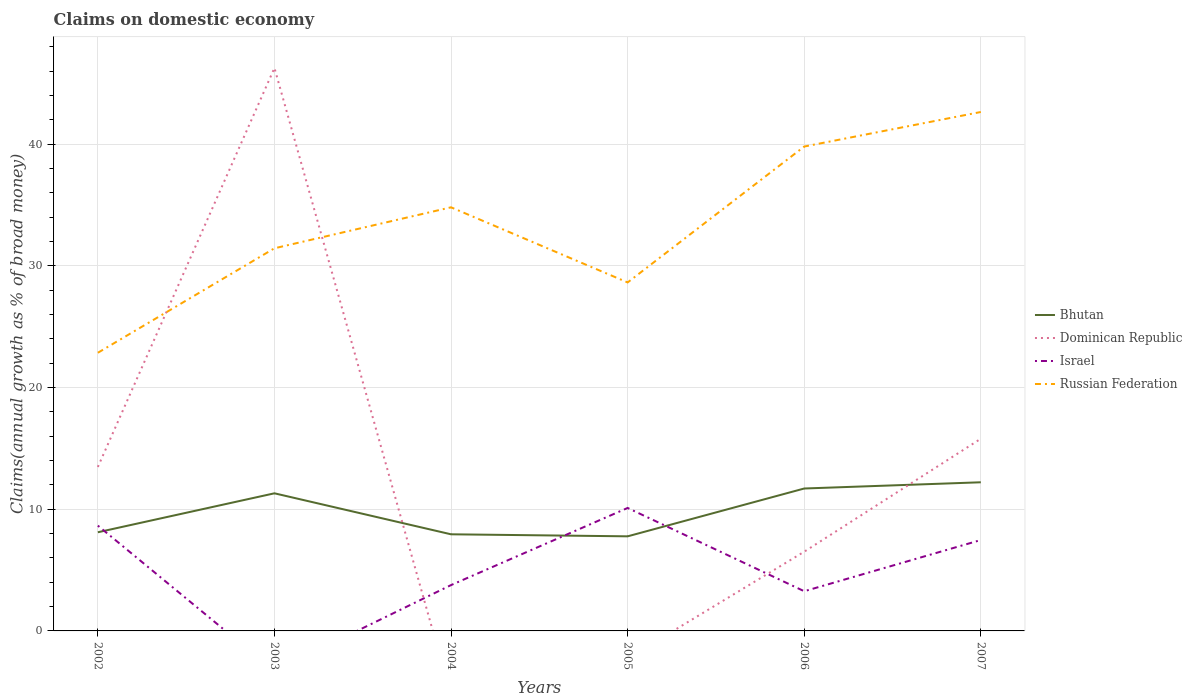Does the line corresponding to Bhutan intersect with the line corresponding to Dominican Republic?
Give a very brief answer. Yes. What is the total percentage of broad money claimed on domestic economy in Israel in the graph?
Provide a succinct answer. 0.51. What is the difference between the highest and the second highest percentage of broad money claimed on domestic economy in Israel?
Your answer should be very brief. 10.1. What is the difference between the highest and the lowest percentage of broad money claimed on domestic economy in Dominican Republic?
Offer a terse response. 2. Is the percentage of broad money claimed on domestic economy in Russian Federation strictly greater than the percentage of broad money claimed on domestic economy in Israel over the years?
Your response must be concise. No. How many lines are there?
Your response must be concise. 4. How many years are there in the graph?
Provide a succinct answer. 6. What is the difference between two consecutive major ticks on the Y-axis?
Provide a succinct answer. 10. Does the graph contain any zero values?
Provide a short and direct response. Yes. What is the title of the graph?
Your response must be concise. Claims on domestic economy. What is the label or title of the Y-axis?
Keep it short and to the point. Claims(annual growth as % of broad money). What is the Claims(annual growth as % of broad money) in Bhutan in 2002?
Keep it short and to the point. 8.11. What is the Claims(annual growth as % of broad money) of Dominican Republic in 2002?
Provide a short and direct response. 13.47. What is the Claims(annual growth as % of broad money) in Israel in 2002?
Ensure brevity in your answer.  8.65. What is the Claims(annual growth as % of broad money) of Russian Federation in 2002?
Offer a terse response. 22.86. What is the Claims(annual growth as % of broad money) of Bhutan in 2003?
Ensure brevity in your answer.  11.31. What is the Claims(annual growth as % of broad money) in Dominican Republic in 2003?
Your response must be concise. 46.26. What is the Claims(annual growth as % of broad money) in Russian Federation in 2003?
Provide a short and direct response. 31.44. What is the Claims(annual growth as % of broad money) of Bhutan in 2004?
Provide a short and direct response. 7.94. What is the Claims(annual growth as % of broad money) of Israel in 2004?
Ensure brevity in your answer.  3.77. What is the Claims(annual growth as % of broad money) in Russian Federation in 2004?
Your response must be concise. 34.81. What is the Claims(annual growth as % of broad money) of Bhutan in 2005?
Give a very brief answer. 7.77. What is the Claims(annual growth as % of broad money) in Dominican Republic in 2005?
Provide a short and direct response. 0. What is the Claims(annual growth as % of broad money) in Israel in 2005?
Your answer should be compact. 10.1. What is the Claims(annual growth as % of broad money) in Russian Federation in 2005?
Your answer should be very brief. 28.63. What is the Claims(annual growth as % of broad money) in Bhutan in 2006?
Provide a short and direct response. 11.7. What is the Claims(annual growth as % of broad money) of Dominican Republic in 2006?
Keep it short and to the point. 6.51. What is the Claims(annual growth as % of broad money) of Israel in 2006?
Your answer should be very brief. 3.26. What is the Claims(annual growth as % of broad money) of Russian Federation in 2006?
Provide a succinct answer. 39.8. What is the Claims(annual growth as % of broad money) of Bhutan in 2007?
Your answer should be very brief. 12.21. What is the Claims(annual growth as % of broad money) in Dominican Republic in 2007?
Give a very brief answer. 15.79. What is the Claims(annual growth as % of broad money) in Israel in 2007?
Keep it short and to the point. 7.47. What is the Claims(annual growth as % of broad money) in Russian Federation in 2007?
Make the answer very short. 42.64. Across all years, what is the maximum Claims(annual growth as % of broad money) in Bhutan?
Offer a very short reply. 12.21. Across all years, what is the maximum Claims(annual growth as % of broad money) in Dominican Republic?
Make the answer very short. 46.26. Across all years, what is the maximum Claims(annual growth as % of broad money) in Israel?
Offer a terse response. 10.1. Across all years, what is the maximum Claims(annual growth as % of broad money) of Russian Federation?
Give a very brief answer. 42.64. Across all years, what is the minimum Claims(annual growth as % of broad money) of Bhutan?
Provide a short and direct response. 7.77. Across all years, what is the minimum Claims(annual growth as % of broad money) of Israel?
Your answer should be compact. 0. Across all years, what is the minimum Claims(annual growth as % of broad money) of Russian Federation?
Your answer should be very brief. 22.86. What is the total Claims(annual growth as % of broad money) of Bhutan in the graph?
Your answer should be compact. 59.04. What is the total Claims(annual growth as % of broad money) in Dominican Republic in the graph?
Provide a short and direct response. 82.03. What is the total Claims(annual growth as % of broad money) in Israel in the graph?
Provide a succinct answer. 33.25. What is the total Claims(annual growth as % of broad money) of Russian Federation in the graph?
Provide a succinct answer. 200.18. What is the difference between the Claims(annual growth as % of broad money) in Bhutan in 2002 and that in 2003?
Offer a terse response. -3.2. What is the difference between the Claims(annual growth as % of broad money) in Dominican Republic in 2002 and that in 2003?
Give a very brief answer. -32.79. What is the difference between the Claims(annual growth as % of broad money) of Russian Federation in 2002 and that in 2003?
Your response must be concise. -8.59. What is the difference between the Claims(annual growth as % of broad money) in Bhutan in 2002 and that in 2004?
Offer a terse response. 0.17. What is the difference between the Claims(annual growth as % of broad money) of Israel in 2002 and that in 2004?
Your answer should be very brief. 4.89. What is the difference between the Claims(annual growth as % of broad money) in Russian Federation in 2002 and that in 2004?
Keep it short and to the point. -11.95. What is the difference between the Claims(annual growth as % of broad money) in Bhutan in 2002 and that in 2005?
Offer a terse response. 0.33. What is the difference between the Claims(annual growth as % of broad money) in Israel in 2002 and that in 2005?
Ensure brevity in your answer.  -1.45. What is the difference between the Claims(annual growth as % of broad money) in Russian Federation in 2002 and that in 2005?
Make the answer very short. -5.78. What is the difference between the Claims(annual growth as % of broad money) in Bhutan in 2002 and that in 2006?
Ensure brevity in your answer.  -3.6. What is the difference between the Claims(annual growth as % of broad money) in Dominican Republic in 2002 and that in 2006?
Offer a very short reply. 6.96. What is the difference between the Claims(annual growth as % of broad money) of Israel in 2002 and that in 2006?
Keep it short and to the point. 5.39. What is the difference between the Claims(annual growth as % of broad money) in Russian Federation in 2002 and that in 2006?
Give a very brief answer. -16.95. What is the difference between the Claims(annual growth as % of broad money) in Bhutan in 2002 and that in 2007?
Offer a very short reply. -4.11. What is the difference between the Claims(annual growth as % of broad money) in Dominican Republic in 2002 and that in 2007?
Provide a succinct answer. -2.32. What is the difference between the Claims(annual growth as % of broad money) of Israel in 2002 and that in 2007?
Provide a short and direct response. 1.18. What is the difference between the Claims(annual growth as % of broad money) in Russian Federation in 2002 and that in 2007?
Keep it short and to the point. -19.78. What is the difference between the Claims(annual growth as % of broad money) of Bhutan in 2003 and that in 2004?
Give a very brief answer. 3.37. What is the difference between the Claims(annual growth as % of broad money) in Russian Federation in 2003 and that in 2004?
Provide a succinct answer. -3.37. What is the difference between the Claims(annual growth as % of broad money) in Bhutan in 2003 and that in 2005?
Provide a succinct answer. 3.54. What is the difference between the Claims(annual growth as % of broad money) of Russian Federation in 2003 and that in 2005?
Provide a succinct answer. 2.81. What is the difference between the Claims(annual growth as % of broad money) of Bhutan in 2003 and that in 2006?
Ensure brevity in your answer.  -0.39. What is the difference between the Claims(annual growth as % of broad money) in Dominican Republic in 2003 and that in 2006?
Provide a short and direct response. 39.75. What is the difference between the Claims(annual growth as % of broad money) in Russian Federation in 2003 and that in 2006?
Your answer should be compact. -8.36. What is the difference between the Claims(annual growth as % of broad money) of Bhutan in 2003 and that in 2007?
Keep it short and to the point. -0.91. What is the difference between the Claims(annual growth as % of broad money) of Dominican Republic in 2003 and that in 2007?
Provide a short and direct response. 30.47. What is the difference between the Claims(annual growth as % of broad money) of Russian Federation in 2003 and that in 2007?
Provide a short and direct response. -11.2. What is the difference between the Claims(annual growth as % of broad money) of Bhutan in 2004 and that in 2005?
Offer a very short reply. 0.17. What is the difference between the Claims(annual growth as % of broad money) in Israel in 2004 and that in 2005?
Keep it short and to the point. -6.34. What is the difference between the Claims(annual growth as % of broad money) of Russian Federation in 2004 and that in 2005?
Make the answer very short. 6.17. What is the difference between the Claims(annual growth as % of broad money) in Bhutan in 2004 and that in 2006?
Offer a very short reply. -3.76. What is the difference between the Claims(annual growth as % of broad money) of Israel in 2004 and that in 2006?
Offer a terse response. 0.51. What is the difference between the Claims(annual growth as % of broad money) in Russian Federation in 2004 and that in 2006?
Provide a succinct answer. -4.99. What is the difference between the Claims(annual growth as % of broad money) in Bhutan in 2004 and that in 2007?
Give a very brief answer. -4.28. What is the difference between the Claims(annual growth as % of broad money) in Israel in 2004 and that in 2007?
Keep it short and to the point. -3.7. What is the difference between the Claims(annual growth as % of broad money) of Russian Federation in 2004 and that in 2007?
Offer a very short reply. -7.83. What is the difference between the Claims(annual growth as % of broad money) of Bhutan in 2005 and that in 2006?
Ensure brevity in your answer.  -3.93. What is the difference between the Claims(annual growth as % of broad money) of Israel in 2005 and that in 2006?
Give a very brief answer. 6.84. What is the difference between the Claims(annual growth as % of broad money) in Russian Federation in 2005 and that in 2006?
Provide a short and direct response. -11.17. What is the difference between the Claims(annual growth as % of broad money) in Bhutan in 2005 and that in 2007?
Provide a short and direct response. -4.44. What is the difference between the Claims(annual growth as % of broad money) in Israel in 2005 and that in 2007?
Your response must be concise. 2.63. What is the difference between the Claims(annual growth as % of broad money) of Russian Federation in 2005 and that in 2007?
Provide a short and direct response. -14. What is the difference between the Claims(annual growth as % of broad money) in Bhutan in 2006 and that in 2007?
Give a very brief answer. -0.51. What is the difference between the Claims(annual growth as % of broad money) of Dominican Republic in 2006 and that in 2007?
Provide a short and direct response. -9.28. What is the difference between the Claims(annual growth as % of broad money) in Israel in 2006 and that in 2007?
Your answer should be very brief. -4.21. What is the difference between the Claims(annual growth as % of broad money) in Russian Federation in 2006 and that in 2007?
Give a very brief answer. -2.84. What is the difference between the Claims(annual growth as % of broad money) in Bhutan in 2002 and the Claims(annual growth as % of broad money) in Dominican Republic in 2003?
Make the answer very short. -38.15. What is the difference between the Claims(annual growth as % of broad money) of Bhutan in 2002 and the Claims(annual growth as % of broad money) of Russian Federation in 2003?
Offer a terse response. -23.33. What is the difference between the Claims(annual growth as % of broad money) of Dominican Republic in 2002 and the Claims(annual growth as % of broad money) of Russian Federation in 2003?
Your answer should be compact. -17.97. What is the difference between the Claims(annual growth as % of broad money) in Israel in 2002 and the Claims(annual growth as % of broad money) in Russian Federation in 2003?
Keep it short and to the point. -22.79. What is the difference between the Claims(annual growth as % of broad money) in Bhutan in 2002 and the Claims(annual growth as % of broad money) in Israel in 2004?
Give a very brief answer. 4.34. What is the difference between the Claims(annual growth as % of broad money) in Bhutan in 2002 and the Claims(annual growth as % of broad money) in Russian Federation in 2004?
Make the answer very short. -26.7. What is the difference between the Claims(annual growth as % of broad money) of Dominican Republic in 2002 and the Claims(annual growth as % of broad money) of Israel in 2004?
Give a very brief answer. 9.71. What is the difference between the Claims(annual growth as % of broad money) in Dominican Republic in 2002 and the Claims(annual growth as % of broad money) in Russian Federation in 2004?
Give a very brief answer. -21.34. What is the difference between the Claims(annual growth as % of broad money) of Israel in 2002 and the Claims(annual growth as % of broad money) of Russian Federation in 2004?
Ensure brevity in your answer.  -26.16. What is the difference between the Claims(annual growth as % of broad money) in Bhutan in 2002 and the Claims(annual growth as % of broad money) in Israel in 2005?
Your answer should be very brief. -2. What is the difference between the Claims(annual growth as % of broad money) in Bhutan in 2002 and the Claims(annual growth as % of broad money) in Russian Federation in 2005?
Make the answer very short. -20.53. What is the difference between the Claims(annual growth as % of broad money) of Dominican Republic in 2002 and the Claims(annual growth as % of broad money) of Israel in 2005?
Your answer should be compact. 3.37. What is the difference between the Claims(annual growth as % of broad money) in Dominican Republic in 2002 and the Claims(annual growth as % of broad money) in Russian Federation in 2005?
Your response must be concise. -15.16. What is the difference between the Claims(annual growth as % of broad money) in Israel in 2002 and the Claims(annual growth as % of broad money) in Russian Federation in 2005?
Offer a terse response. -19.98. What is the difference between the Claims(annual growth as % of broad money) of Bhutan in 2002 and the Claims(annual growth as % of broad money) of Dominican Republic in 2006?
Your answer should be compact. 1.6. What is the difference between the Claims(annual growth as % of broad money) in Bhutan in 2002 and the Claims(annual growth as % of broad money) in Israel in 2006?
Provide a short and direct response. 4.85. What is the difference between the Claims(annual growth as % of broad money) of Bhutan in 2002 and the Claims(annual growth as % of broad money) of Russian Federation in 2006?
Provide a succinct answer. -31.69. What is the difference between the Claims(annual growth as % of broad money) in Dominican Republic in 2002 and the Claims(annual growth as % of broad money) in Israel in 2006?
Keep it short and to the point. 10.21. What is the difference between the Claims(annual growth as % of broad money) in Dominican Republic in 2002 and the Claims(annual growth as % of broad money) in Russian Federation in 2006?
Make the answer very short. -26.33. What is the difference between the Claims(annual growth as % of broad money) in Israel in 2002 and the Claims(annual growth as % of broad money) in Russian Federation in 2006?
Give a very brief answer. -31.15. What is the difference between the Claims(annual growth as % of broad money) in Bhutan in 2002 and the Claims(annual growth as % of broad money) in Dominican Republic in 2007?
Offer a very short reply. -7.69. What is the difference between the Claims(annual growth as % of broad money) in Bhutan in 2002 and the Claims(annual growth as % of broad money) in Israel in 2007?
Provide a short and direct response. 0.64. What is the difference between the Claims(annual growth as % of broad money) of Bhutan in 2002 and the Claims(annual growth as % of broad money) of Russian Federation in 2007?
Your answer should be compact. -34.53. What is the difference between the Claims(annual growth as % of broad money) of Dominican Republic in 2002 and the Claims(annual growth as % of broad money) of Israel in 2007?
Ensure brevity in your answer.  6. What is the difference between the Claims(annual growth as % of broad money) of Dominican Republic in 2002 and the Claims(annual growth as % of broad money) of Russian Federation in 2007?
Provide a short and direct response. -29.17. What is the difference between the Claims(annual growth as % of broad money) in Israel in 2002 and the Claims(annual growth as % of broad money) in Russian Federation in 2007?
Make the answer very short. -33.99. What is the difference between the Claims(annual growth as % of broad money) of Bhutan in 2003 and the Claims(annual growth as % of broad money) of Israel in 2004?
Your response must be concise. 7.54. What is the difference between the Claims(annual growth as % of broad money) of Bhutan in 2003 and the Claims(annual growth as % of broad money) of Russian Federation in 2004?
Provide a short and direct response. -23.5. What is the difference between the Claims(annual growth as % of broad money) of Dominican Republic in 2003 and the Claims(annual growth as % of broad money) of Israel in 2004?
Keep it short and to the point. 42.49. What is the difference between the Claims(annual growth as % of broad money) in Dominican Republic in 2003 and the Claims(annual growth as % of broad money) in Russian Federation in 2004?
Offer a very short reply. 11.45. What is the difference between the Claims(annual growth as % of broad money) of Bhutan in 2003 and the Claims(annual growth as % of broad money) of Israel in 2005?
Keep it short and to the point. 1.2. What is the difference between the Claims(annual growth as % of broad money) of Bhutan in 2003 and the Claims(annual growth as % of broad money) of Russian Federation in 2005?
Your response must be concise. -17.33. What is the difference between the Claims(annual growth as % of broad money) in Dominican Republic in 2003 and the Claims(annual growth as % of broad money) in Israel in 2005?
Keep it short and to the point. 36.15. What is the difference between the Claims(annual growth as % of broad money) in Dominican Republic in 2003 and the Claims(annual growth as % of broad money) in Russian Federation in 2005?
Offer a very short reply. 17.62. What is the difference between the Claims(annual growth as % of broad money) of Bhutan in 2003 and the Claims(annual growth as % of broad money) of Dominican Republic in 2006?
Your answer should be compact. 4.8. What is the difference between the Claims(annual growth as % of broad money) in Bhutan in 2003 and the Claims(annual growth as % of broad money) in Israel in 2006?
Your response must be concise. 8.05. What is the difference between the Claims(annual growth as % of broad money) in Bhutan in 2003 and the Claims(annual growth as % of broad money) in Russian Federation in 2006?
Provide a succinct answer. -28.49. What is the difference between the Claims(annual growth as % of broad money) in Dominican Republic in 2003 and the Claims(annual growth as % of broad money) in Israel in 2006?
Your response must be concise. 43. What is the difference between the Claims(annual growth as % of broad money) in Dominican Republic in 2003 and the Claims(annual growth as % of broad money) in Russian Federation in 2006?
Keep it short and to the point. 6.46. What is the difference between the Claims(annual growth as % of broad money) of Bhutan in 2003 and the Claims(annual growth as % of broad money) of Dominican Republic in 2007?
Your answer should be very brief. -4.48. What is the difference between the Claims(annual growth as % of broad money) in Bhutan in 2003 and the Claims(annual growth as % of broad money) in Israel in 2007?
Offer a terse response. 3.84. What is the difference between the Claims(annual growth as % of broad money) of Bhutan in 2003 and the Claims(annual growth as % of broad money) of Russian Federation in 2007?
Offer a terse response. -31.33. What is the difference between the Claims(annual growth as % of broad money) of Dominican Republic in 2003 and the Claims(annual growth as % of broad money) of Israel in 2007?
Your answer should be very brief. 38.79. What is the difference between the Claims(annual growth as % of broad money) of Dominican Republic in 2003 and the Claims(annual growth as % of broad money) of Russian Federation in 2007?
Offer a very short reply. 3.62. What is the difference between the Claims(annual growth as % of broad money) of Bhutan in 2004 and the Claims(annual growth as % of broad money) of Israel in 2005?
Offer a very short reply. -2.17. What is the difference between the Claims(annual growth as % of broad money) of Bhutan in 2004 and the Claims(annual growth as % of broad money) of Russian Federation in 2005?
Your response must be concise. -20.7. What is the difference between the Claims(annual growth as % of broad money) of Israel in 2004 and the Claims(annual growth as % of broad money) of Russian Federation in 2005?
Ensure brevity in your answer.  -24.87. What is the difference between the Claims(annual growth as % of broad money) in Bhutan in 2004 and the Claims(annual growth as % of broad money) in Dominican Republic in 2006?
Ensure brevity in your answer.  1.43. What is the difference between the Claims(annual growth as % of broad money) in Bhutan in 2004 and the Claims(annual growth as % of broad money) in Israel in 2006?
Give a very brief answer. 4.68. What is the difference between the Claims(annual growth as % of broad money) of Bhutan in 2004 and the Claims(annual growth as % of broad money) of Russian Federation in 2006?
Ensure brevity in your answer.  -31.86. What is the difference between the Claims(annual growth as % of broad money) in Israel in 2004 and the Claims(annual growth as % of broad money) in Russian Federation in 2006?
Your response must be concise. -36.03. What is the difference between the Claims(annual growth as % of broad money) of Bhutan in 2004 and the Claims(annual growth as % of broad money) of Dominican Republic in 2007?
Your answer should be very brief. -7.85. What is the difference between the Claims(annual growth as % of broad money) in Bhutan in 2004 and the Claims(annual growth as % of broad money) in Israel in 2007?
Your answer should be very brief. 0.47. What is the difference between the Claims(annual growth as % of broad money) in Bhutan in 2004 and the Claims(annual growth as % of broad money) in Russian Federation in 2007?
Give a very brief answer. -34.7. What is the difference between the Claims(annual growth as % of broad money) in Israel in 2004 and the Claims(annual growth as % of broad money) in Russian Federation in 2007?
Ensure brevity in your answer.  -38.87. What is the difference between the Claims(annual growth as % of broad money) in Bhutan in 2005 and the Claims(annual growth as % of broad money) in Dominican Republic in 2006?
Give a very brief answer. 1.26. What is the difference between the Claims(annual growth as % of broad money) in Bhutan in 2005 and the Claims(annual growth as % of broad money) in Israel in 2006?
Offer a terse response. 4.51. What is the difference between the Claims(annual growth as % of broad money) in Bhutan in 2005 and the Claims(annual growth as % of broad money) in Russian Federation in 2006?
Your response must be concise. -32.03. What is the difference between the Claims(annual growth as % of broad money) in Israel in 2005 and the Claims(annual growth as % of broad money) in Russian Federation in 2006?
Your answer should be compact. -29.7. What is the difference between the Claims(annual growth as % of broad money) in Bhutan in 2005 and the Claims(annual growth as % of broad money) in Dominican Republic in 2007?
Make the answer very short. -8.02. What is the difference between the Claims(annual growth as % of broad money) in Bhutan in 2005 and the Claims(annual growth as % of broad money) in Israel in 2007?
Offer a very short reply. 0.3. What is the difference between the Claims(annual growth as % of broad money) of Bhutan in 2005 and the Claims(annual growth as % of broad money) of Russian Federation in 2007?
Make the answer very short. -34.87. What is the difference between the Claims(annual growth as % of broad money) in Israel in 2005 and the Claims(annual growth as % of broad money) in Russian Federation in 2007?
Offer a very short reply. -32.54. What is the difference between the Claims(annual growth as % of broad money) in Bhutan in 2006 and the Claims(annual growth as % of broad money) in Dominican Republic in 2007?
Ensure brevity in your answer.  -4.09. What is the difference between the Claims(annual growth as % of broad money) of Bhutan in 2006 and the Claims(annual growth as % of broad money) of Israel in 2007?
Keep it short and to the point. 4.23. What is the difference between the Claims(annual growth as % of broad money) in Bhutan in 2006 and the Claims(annual growth as % of broad money) in Russian Federation in 2007?
Offer a terse response. -30.94. What is the difference between the Claims(annual growth as % of broad money) in Dominican Republic in 2006 and the Claims(annual growth as % of broad money) in Israel in 2007?
Give a very brief answer. -0.96. What is the difference between the Claims(annual growth as % of broad money) in Dominican Republic in 2006 and the Claims(annual growth as % of broad money) in Russian Federation in 2007?
Offer a very short reply. -36.13. What is the difference between the Claims(annual growth as % of broad money) in Israel in 2006 and the Claims(annual growth as % of broad money) in Russian Federation in 2007?
Make the answer very short. -39.38. What is the average Claims(annual growth as % of broad money) of Bhutan per year?
Your response must be concise. 9.84. What is the average Claims(annual growth as % of broad money) of Dominican Republic per year?
Make the answer very short. 13.67. What is the average Claims(annual growth as % of broad money) in Israel per year?
Offer a terse response. 5.54. What is the average Claims(annual growth as % of broad money) in Russian Federation per year?
Your answer should be compact. 33.36. In the year 2002, what is the difference between the Claims(annual growth as % of broad money) of Bhutan and Claims(annual growth as % of broad money) of Dominican Republic?
Ensure brevity in your answer.  -5.37. In the year 2002, what is the difference between the Claims(annual growth as % of broad money) of Bhutan and Claims(annual growth as % of broad money) of Israel?
Give a very brief answer. -0.55. In the year 2002, what is the difference between the Claims(annual growth as % of broad money) in Bhutan and Claims(annual growth as % of broad money) in Russian Federation?
Ensure brevity in your answer.  -14.75. In the year 2002, what is the difference between the Claims(annual growth as % of broad money) in Dominican Republic and Claims(annual growth as % of broad money) in Israel?
Give a very brief answer. 4.82. In the year 2002, what is the difference between the Claims(annual growth as % of broad money) in Dominican Republic and Claims(annual growth as % of broad money) in Russian Federation?
Ensure brevity in your answer.  -9.38. In the year 2002, what is the difference between the Claims(annual growth as % of broad money) in Israel and Claims(annual growth as % of broad money) in Russian Federation?
Offer a very short reply. -14.2. In the year 2003, what is the difference between the Claims(annual growth as % of broad money) of Bhutan and Claims(annual growth as % of broad money) of Dominican Republic?
Ensure brevity in your answer.  -34.95. In the year 2003, what is the difference between the Claims(annual growth as % of broad money) of Bhutan and Claims(annual growth as % of broad money) of Russian Federation?
Offer a terse response. -20.13. In the year 2003, what is the difference between the Claims(annual growth as % of broad money) in Dominican Republic and Claims(annual growth as % of broad money) in Russian Federation?
Provide a succinct answer. 14.82. In the year 2004, what is the difference between the Claims(annual growth as % of broad money) in Bhutan and Claims(annual growth as % of broad money) in Israel?
Ensure brevity in your answer.  4.17. In the year 2004, what is the difference between the Claims(annual growth as % of broad money) of Bhutan and Claims(annual growth as % of broad money) of Russian Federation?
Your response must be concise. -26.87. In the year 2004, what is the difference between the Claims(annual growth as % of broad money) of Israel and Claims(annual growth as % of broad money) of Russian Federation?
Give a very brief answer. -31.04. In the year 2005, what is the difference between the Claims(annual growth as % of broad money) in Bhutan and Claims(annual growth as % of broad money) in Israel?
Keep it short and to the point. -2.33. In the year 2005, what is the difference between the Claims(annual growth as % of broad money) in Bhutan and Claims(annual growth as % of broad money) in Russian Federation?
Provide a short and direct response. -20.86. In the year 2005, what is the difference between the Claims(annual growth as % of broad money) in Israel and Claims(annual growth as % of broad money) in Russian Federation?
Your answer should be compact. -18.53. In the year 2006, what is the difference between the Claims(annual growth as % of broad money) in Bhutan and Claims(annual growth as % of broad money) in Dominican Republic?
Your answer should be very brief. 5.19. In the year 2006, what is the difference between the Claims(annual growth as % of broad money) in Bhutan and Claims(annual growth as % of broad money) in Israel?
Your answer should be compact. 8.44. In the year 2006, what is the difference between the Claims(annual growth as % of broad money) in Bhutan and Claims(annual growth as % of broad money) in Russian Federation?
Provide a short and direct response. -28.1. In the year 2006, what is the difference between the Claims(annual growth as % of broad money) in Dominican Republic and Claims(annual growth as % of broad money) in Israel?
Ensure brevity in your answer.  3.25. In the year 2006, what is the difference between the Claims(annual growth as % of broad money) in Dominican Republic and Claims(annual growth as % of broad money) in Russian Federation?
Give a very brief answer. -33.29. In the year 2006, what is the difference between the Claims(annual growth as % of broad money) of Israel and Claims(annual growth as % of broad money) of Russian Federation?
Keep it short and to the point. -36.54. In the year 2007, what is the difference between the Claims(annual growth as % of broad money) of Bhutan and Claims(annual growth as % of broad money) of Dominican Republic?
Make the answer very short. -3.58. In the year 2007, what is the difference between the Claims(annual growth as % of broad money) in Bhutan and Claims(annual growth as % of broad money) in Israel?
Keep it short and to the point. 4.75. In the year 2007, what is the difference between the Claims(annual growth as % of broad money) of Bhutan and Claims(annual growth as % of broad money) of Russian Federation?
Provide a succinct answer. -30.43. In the year 2007, what is the difference between the Claims(annual growth as % of broad money) in Dominican Republic and Claims(annual growth as % of broad money) in Israel?
Your answer should be very brief. 8.32. In the year 2007, what is the difference between the Claims(annual growth as % of broad money) of Dominican Republic and Claims(annual growth as % of broad money) of Russian Federation?
Offer a very short reply. -26.85. In the year 2007, what is the difference between the Claims(annual growth as % of broad money) of Israel and Claims(annual growth as % of broad money) of Russian Federation?
Offer a very short reply. -35.17. What is the ratio of the Claims(annual growth as % of broad money) of Bhutan in 2002 to that in 2003?
Keep it short and to the point. 0.72. What is the ratio of the Claims(annual growth as % of broad money) of Dominican Republic in 2002 to that in 2003?
Provide a succinct answer. 0.29. What is the ratio of the Claims(annual growth as % of broad money) in Russian Federation in 2002 to that in 2003?
Keep it short and to the point. 0.73. What is the ratio of the Claims(annual growth as % of broad money) in Bhutan in 2002 to that in 2004?
Give a very brief answer. 1.02. What is the ratio of the Claims(annual growth as % of broad money) in Israel in 2002 to that in 2004?
Your answer should be very brief. 2.3. What is the ratio of the Claims(annual growth as % of broad money) in Russian Federation in 2002 to that in 2004?
Your response must be concise. 0.66. What is the ratio of the Claims(annual growth as % of broad money) of Bhutan in 2002 to that in 2005?
Ensure brevity in your answer.  1.04. What is the ratio of the Claims(annual growth as % of broad money) in Israel in 2002 to that in 2005?
Provide a succinct answer. 0.86. What is the ratio of the Claims(annual growth as % of broad money) of Russian Federation in 2002 to that in 2005?
Keep it short and to the point. 0.8. What is the ratio of the Claims(annual growth as % of broad money) in Bhutan in 2002 to that in 2006?
Keep it short and to the point. 0.69. What is the ratio of the Claims(annual growth as % of broad money) in Dominican Republic in 2002 to that in 2006?
Offer a terse response. 2.07. What is the ratio of the Claims(annual growth as % of broad money) of Israel in 2002 to that in 2006?
Offer a terse response. 2.65. What is the ratio of the Claims(annual growth as % of broad money) in Russian Federation in 2002 to that in 2006?
Your answer should be very brief. 0.57. What is the ratio of the Claims(annual growth as % of broad money) in Bhutan in 2002 to that in 2007?
Your answer should be very brief. 0.66. What is the ratio of the Claims(annual growth as % of broad money) in Dominican Republic in 2002 to that in 2007?
Your answer should be compact. 0.85. What is the ratio of the Claims(annual growth as % of broad money) of Israel in 2002 to that in 2007?
Provide a short and direct response. 1.16. What is the ratio of the Claims(annual growth as % of broad money) of Russian Federation in 2002 to that in 2007?
Give a very brief answer. 0.54. What is the ratio of the Claims(annual growth as % of broad money) in Bhutan in 2003 to that in 2004?
Your answer should be very brief. 1.42. What is the ratio of the Claims(annual growth as % of broad money) in Russian Federation in 2003 to that in 2004?
Give a very brief answer. 0.9. What is the ratio of the Claims(annual growth as % of broad money) in Bhutan in 2003 to that in 2005?
Provide a short and direct response. 1.45. What is the ratio of the Claims(annual growth as % of broad money) of Russian Federation in 2003 to that in 2005?
Keep it short and to the point. 1.1. What is the ratio of the Claims(annual growth as % of broad money) in Bhutan in 2003 to that in 2006?
Provide a succinct answer. 0.97. What is the ratio of the Claims(annual growth as % of broad money) of Dominican Republic in 2003 to that in 2006?
Make the answer very short. 7.11. What is the ratio of the Claims(annual growth as % of broad money) in Russian Federation in 2003 to that in 2006?
Give a very brief answer. 0.79. What is the ratio of the Claims(annual growth as % of broad money) in Bhutan in 2003 to that in 2007?
Your answer should be compact. 0.93. What is the ratio of the Claims(annual growth as % of broad money) of Dominican Republic in 2003 to that in 2007?
Offer a terse response. 2.93. What is the ratio of the Claims(annual growth as % of broad money) of Russian Federation in 2003 to that in 2007?
Your answer should be very brief. 0.74. What is the ratio of the Claims(annual growth as % of broad money) of Bhutan in 2004 to that in 2005?
Ensure brevity in your answer.  1.02. What is the ratio of the Claims(annual growth as % of broad money) in Israel in 2004 to that in 2005?
Your answer should be compact. 0.37. What is the ratio of the Claims(annual growth as % of broad money) in Russian Federation in 2004 to that in 2005?
Ensure brevity in your answer.  1.22. What is the ratio of the Claims(annual growth as % of broad money) of Bhutan in 2004 to that in 2006?
Keep it short and to the point. 0.68. What is the ratio of the Claims(annual growth as % of broad money) of Israel in 2004 to that in 2006?
Give a very brief answer. 1.15. What is the ratio of the Claims(annual growth as % of broad money) of Russian Federation in 2004 to that in 2006?
Give a very brief answer. 0.87. What is the ratio of the Claims(annual growth as % of broad money) of Bhutan in 2004 to that in 2007?
Ensure brevity in your answer.  0.65. What is the ratio of the Claims(annual growth as % of broad money) of Israel in 2004 to that in 2007?
Keep it short and to the point. 0.5. What is the ratio of the Claims(annual growth as % of broad money) in Russian Federation in 2004 to that in 2007?
Your answer should be compact. 0.82. What is the ratio of the Claims(annual growth as % of broad money) of Bhutan in 2005 to that in 2006?
Offer a very short reply. 0.66. What is the ratio of the Claims(annual growth as % of broad money) in Israel in 2005 to that in 2006?
Give a very brief answer. 3.1. What is the ratio of the Claims(annual growth as % of broad money) in Russian Federation in 2005 to that in 2006?
Your answer should be very brief. 0.72. What is the ratio of the Claims(annual growth as % of broad money) in Bhutan in 2005 to that in 2007?
Offer a terse response. 0.64. What is the ratio of the Claims(annual growth as % of broad money) of Israel in 2005 to that in 2007?
Provide a succinct answer. 1.35. What is the ratio of the Claims(annual growth as % of broad money) of Russian Federation in 2005 to that in 2007?
Provide a short and direct response. 0.67. What is the ratio of the Claims(annual growth as % of broad money) of Bhutan in 2006 to that in 2007?
Keep it short and to the point. 0.96. What is the ratio of the Claims(annual growth as % of broad money) in Dominican Republic in 2006 to that in 2007?
Provide a short and direct response. 0.41. What is the ratio of the Claims(annual growth as % of broad money) of Israel in 2006 to that in 2007?
Your answer should be very brief. 0.44. What is the ratio of the Claims(annual growth as % of broad money) of Russian Federation in 2006 to that in 2007?
Ensure brevity in your answer.  0.93. What is the difference between the highest and the second highest Claims(annual growth as % of broad money) in Bhutan?
Your answer should be compact. 0.51. What is the difference between the highest and the second highest Claims(annual growth as % of broad money) in Dominican Republic?
Give a very brief answer. 30.47. What is the difference between the highest and the second highest Claims(annual growth as % of broad money) of Israel?
Make the answer very short. 1.45. What is the difference between the highest and the second highest Claims(annual growth as % of broad money) of Russian Federation?
Give a very brief answer. 2.84. What is the difference between the highest and the lowest Claims(annual growth as % of broad money) in Bhutan?
Provide a short and direct response. 4.44. What is the difference between the highest and the lowest Claims(annual growth as % of broad money) of Dominican Republic?
Your answer should be compact. 46.26. What is the difference between the highest and the lowest Claims(annual growth as % of broad money) of Israel?
Your answer should be very brief. 10.1. What is the difference between the highest and the lowest Claims(annual growth as % of broad money) in Russian Federation?
Your response must be concise. 19.78. 